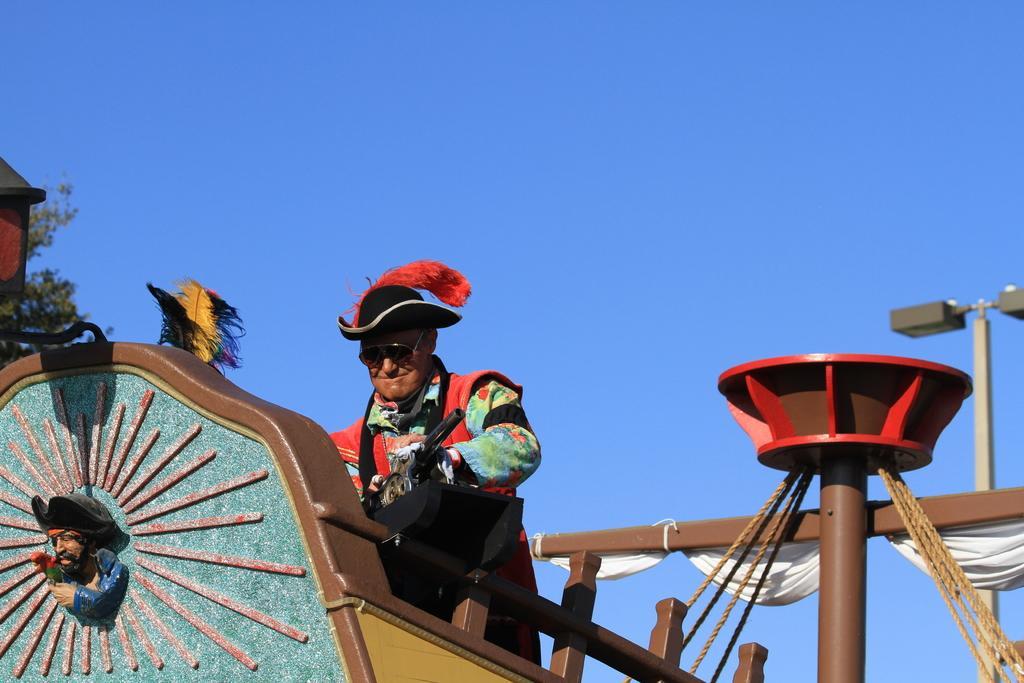How would you summarize this image in a sentence or two? There is a pirate ship and a person standing in that ship, in the background there is a blue sky. 